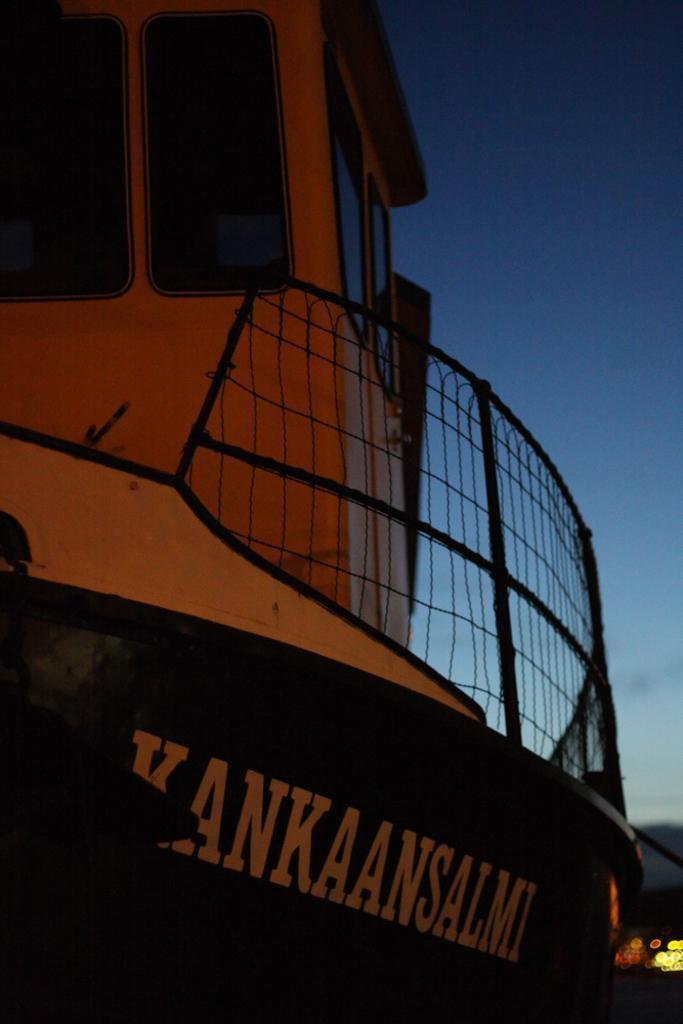Can you describe this image briefly? In the image there is a ship and the background of the ship is blur. 